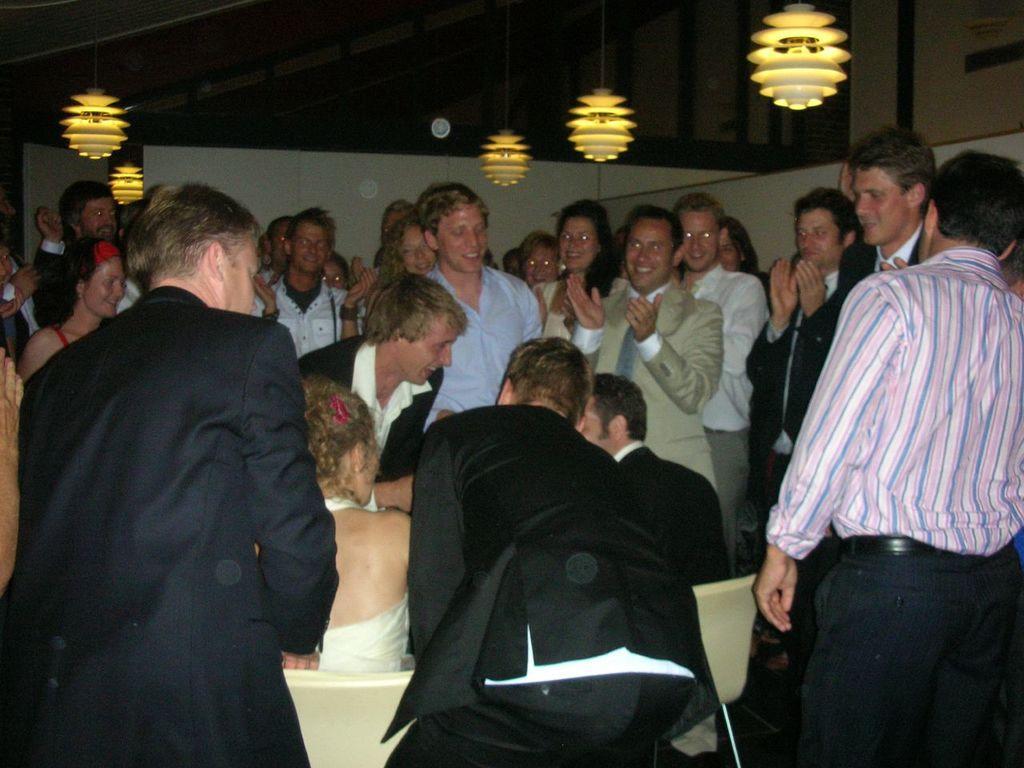Can you describe this image briefly? In the image,there is a couple sitting on the chairs and around them there are many people clapping and wishing them. To the roof there are some lights hanging down. 